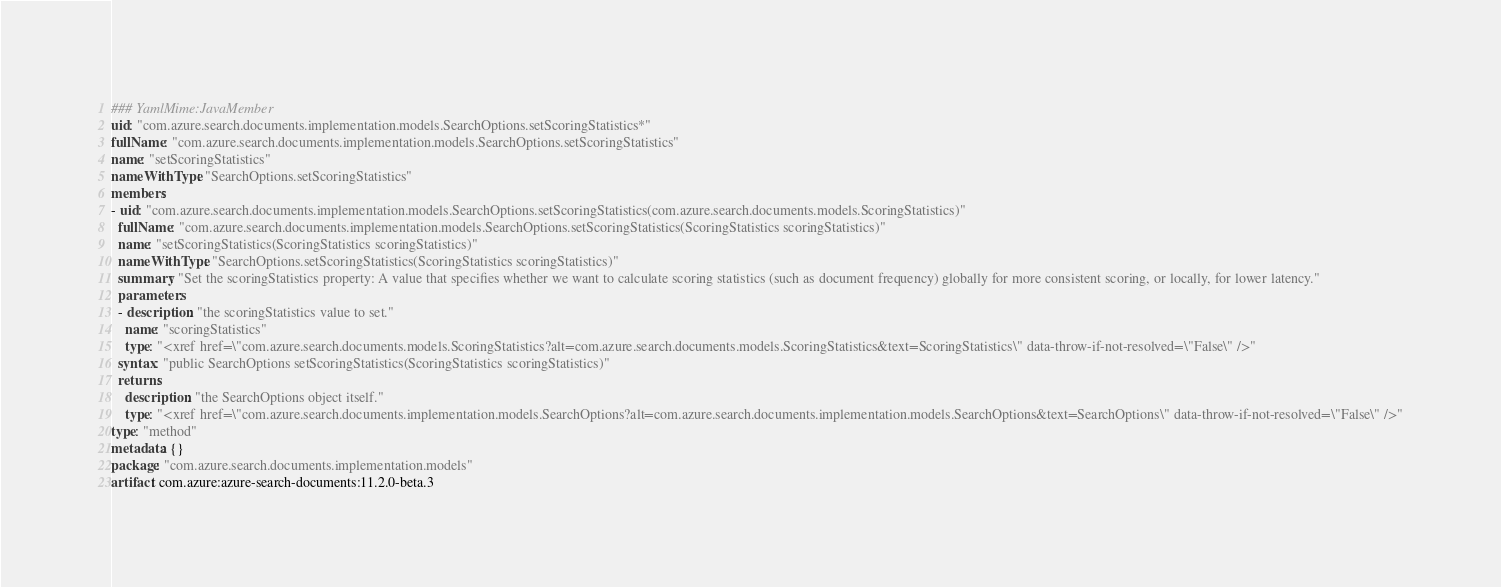<code> <loc_0><loc_0><loc_500><loc_500><_YAML_>### YamlMime:JavaMember
uid: "com.azure.search.documents.implementation.models.SearchOptions.setScoringStatistics*"
fullName: "com.azure.search.documents.implementation.models.SearchOptions.setScoringStatistics"
name: "setScoringStatistics"
nameWithType: "SearchOptions.setScoringStatistics"
members:
- uid: "com.azure.search.documents.implementation.models.SearchOptions.setScoringStatistics(com.azure.search.documents.models.ScoringStatistics)"
  fullName: "com.azure.search.documents.implementation.models.SearchOptions.setScoringStatistics(ScoringStatistics scoringStatistics)"
  name: "setScoringStatistics(ScoringStatistics scoringStatistics)"
  nameWithType: "SearchOptions.setScoringStatistics(ScoringStatistics scoringStatistics)"
  summary: "Set the scoringStatistics property: A value that specifies whether we want to calculate scoring statistics (such as document frequency) globally for more consistent scoring, or locally, for lower latency."
  parameters:
  - description: "the scoringStatistics value to set."
    name: "scoringStatistics"
    type: "<xref href=\"com.azure.search.documents.models.ScoringStatistics?alt=com.azure.search.documents.models.ScoringStatistics&text=ScoringStatistics\" data-throw-if-not-resolved=\"False\" />"
  syntax: "public SearchOptions setScoringStatistics(ScoringStatistics scoringStatistics)"
  returns:
    description: "the SearchOptions object itself."
    type: "<xref href=\"com.azure.search.documents.implementation.models.SearchOptions?alt=com.azure.search.documents.implementation.models.SearchOptions&text=SearchOptions\" data-throw-if-not-resolved=\"False\" />"
type: "method"
metadata: {}
package: "com.azure.search.documents.implementation.models"
artifact: com.azure:azure-search-documents:11.2.0-beta.3
</code> 